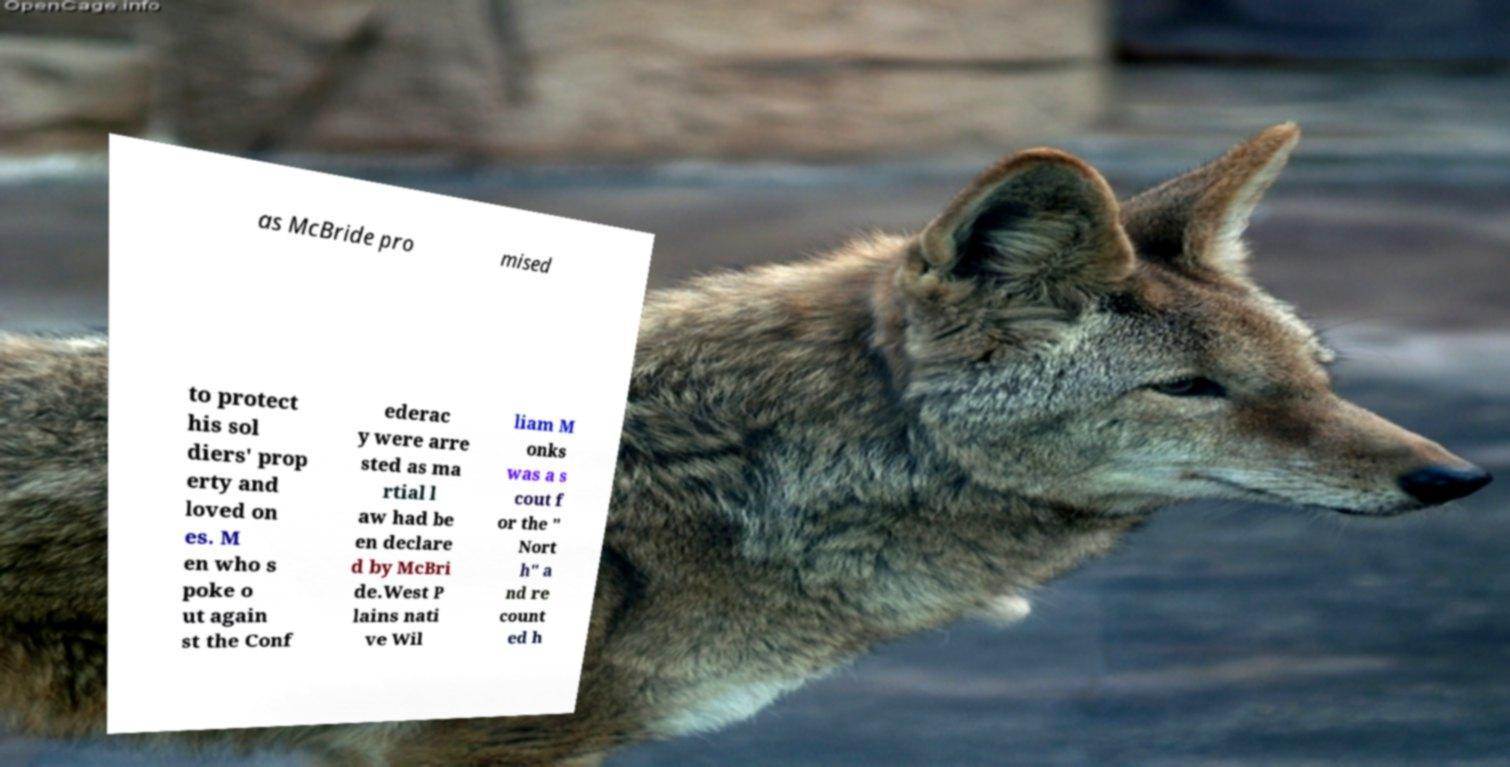What messages or text are displayed in this image? I need them in a readable, typed format. as McBride pro mised to protect his sol diers' prop erty and loved on es. M en who s poke o ut again st the Conf ederac y were arre sted as ma rtial l aw had be en declare d by McBri de.West P lains nati ve Wil liam M onks was a s cout f or the " Nort h" a nd re count ed h 